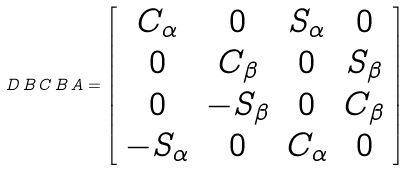Convert formula to latex. <formula><loc_0><loc_0><loc_500><loc_500>D \, B \, C \, B \, A = \left [ \begin{array} { c c c c } C _ { \alpha } & 0 & S _ { \alpha } & 0 \\ 0 & C _ { \beta } & 0 & S _ { \beta } \\ 0 & - S _ { \beta } & 0 & C _ { \beta } \\ - S _ { \alpha } & 0 & C _ { \alpha } & 0 \end{array} \right ]</formula> 